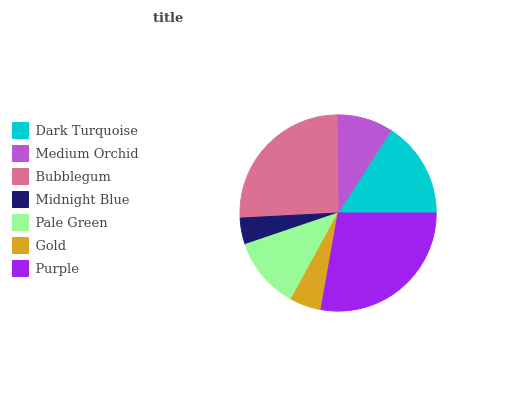Is Midnight Blue the minimum?
Answer yes or no. Yes. Is Purple the maximum?
Answer yes or no. Yes. Is Medium Orchid the minimum?
Answer yes or no. No. Is Medium Orchid the maximum?
Answer yes or no. No. Is Dark Turquoise greater than Medium Orchid?
Answer yes or no. Yes. Is Medium Orchid less than Dark Turquoise?
Answer yes or no. Yes. Is Medium Orchid greater than Dark Turquoise?
Answer yes or no. No. Is Dark Turquoise less than Medium Orchid?
Answer yes or no. No. Is Pale Green the high median?
Answer yes or no. Yes. Is Pale Green the low median?
Answer yes or no. Yes. Is Bubblegum the high median?
Answer yes or no. No. Is Midnight Blue the low median?
Answer yes or no. No. 